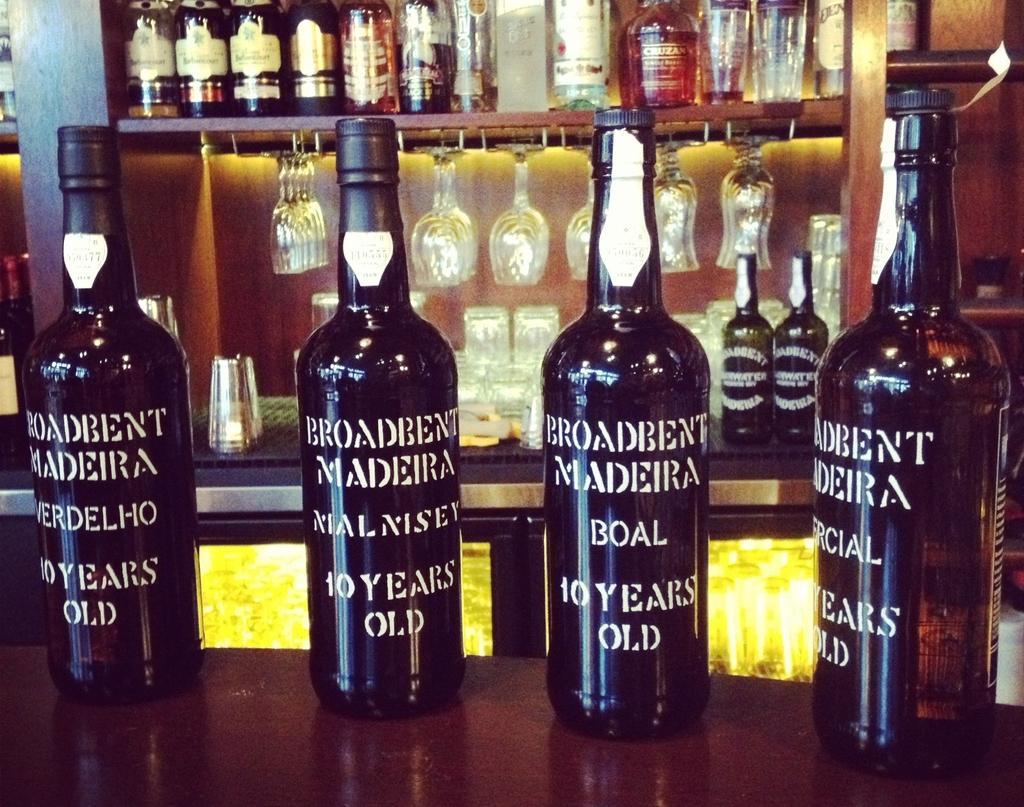<image>
Write a terse but informative summary of the picture. Four bottles of Broadbent Madiera on a bar counter. 